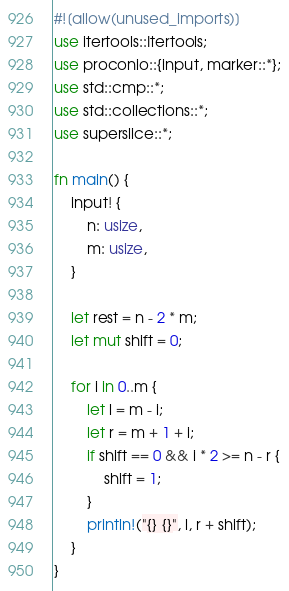<code> <loc_0><loc_0><loc_500><loc_500><_Rust_>#![allow(unused_imports)]
use itertools::Itertools;
use proconio::{input, marker::*};
use std::cmp::*;
use std::collections::*;
use superslice::*;

fn main() {
    input! {
        n: usize,
        m: usize,
    }

    let rest = n - 2 * m;
    let mut shift = 0;

    for i in 0..m {
        let l = m - i;
        let r = m + 1 + i;
        if shift == 0 && i * 2 >= n - r {
            shift = 1;
        }
        println!("{} {}", l, r + shift);
    }
}
</code> 